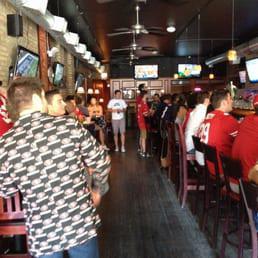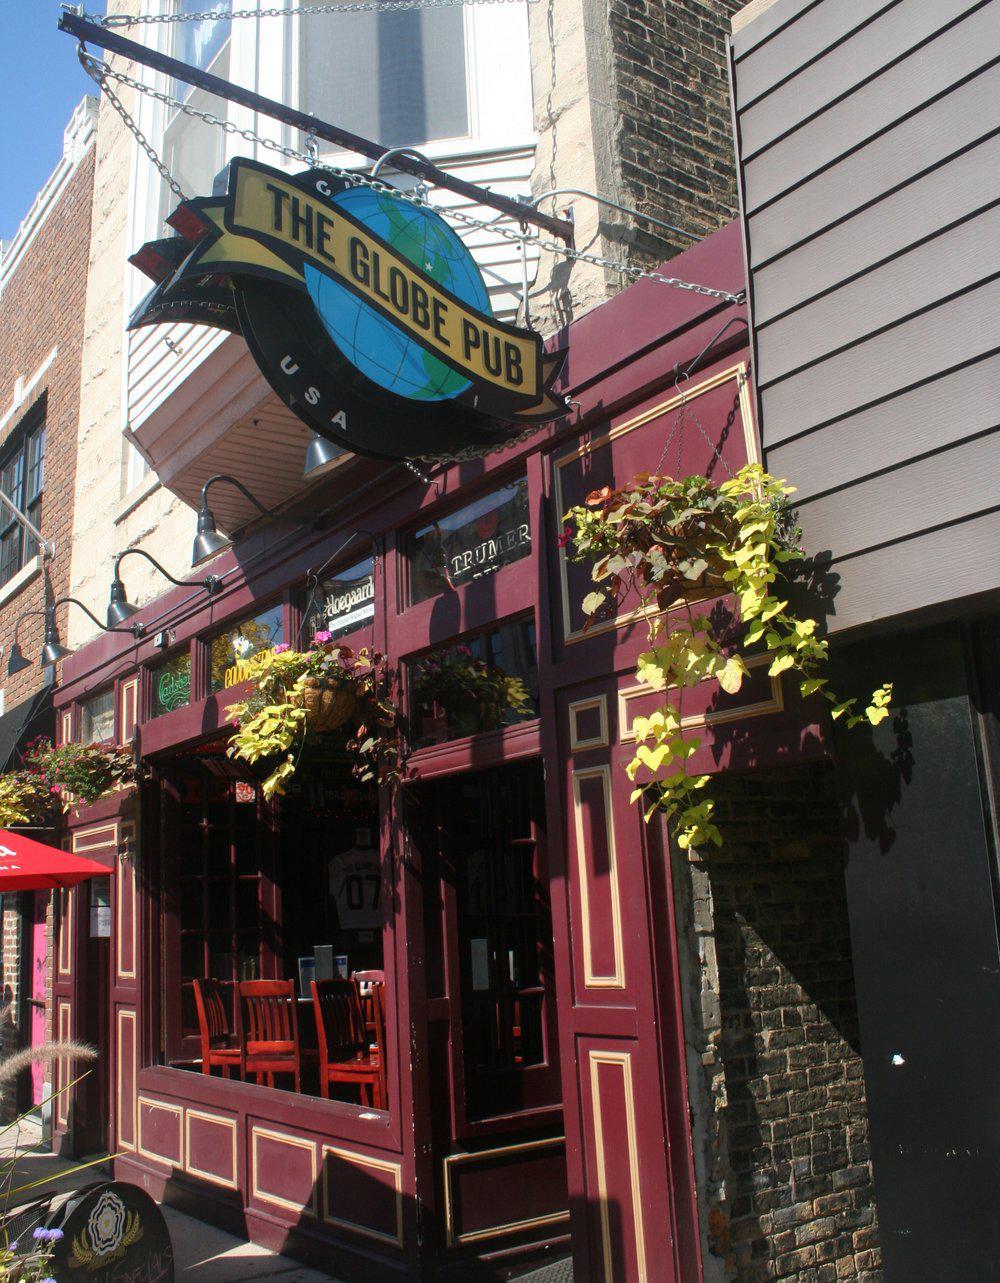The first image is the image on the left, the second image is the image on the right. Evaluate the accuracy of this statement regarding the images: "In at least one image there are three people at the bar looking at a television.". Is it true? Answer yes or no. No. The first image is the image on the left, the second image is the image on the right. Evaluate the accuracy of this statement regarding the images: "There are televisions in exactly one of the imagtes.". Is it true? Answer yes or no. Yes. 